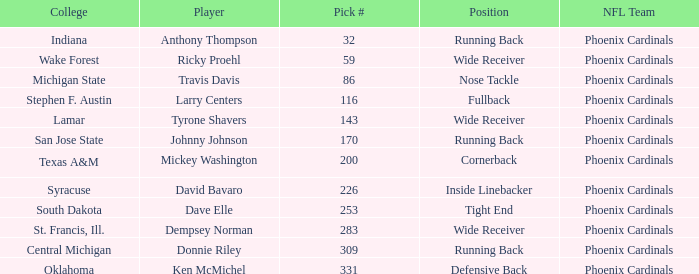What is the pick# from South Dakota college? 253.0. 